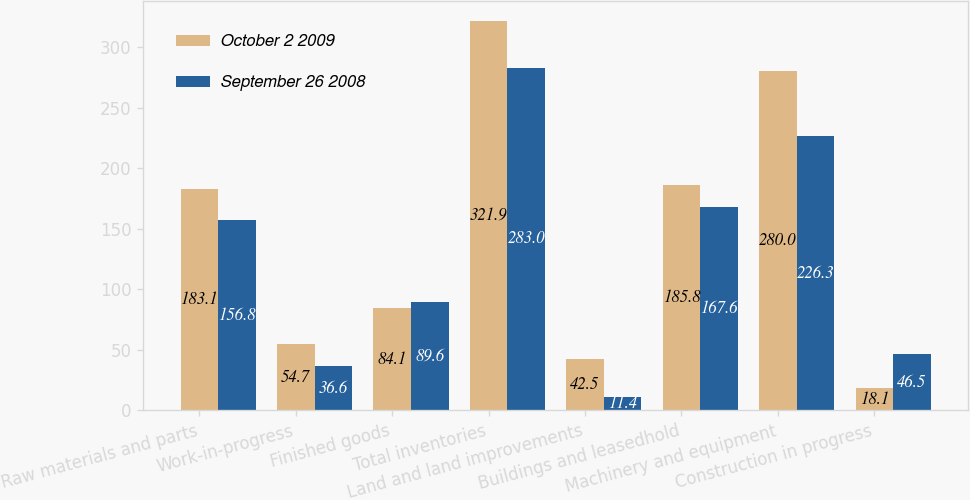Convert chart. <chart><loc_0><loc_0><loc_500><loc_500><stacked_bar_chart><ecel><fcel>Raw materials and parts<fcel>Work-in-progress<fcel>Finished goods<fcel>Total inventories<fcel>Land and land improvements<fcel>Buildings and leasedhold<fcel>Machinery and equipment<fcel>Construction in progress<nl><fcel>October 2 2009<fcel>183.1<fcel>54.7<fcel>84.1<fcel>321.9<fcel>42.5<fcel>185.8<fcel>280<fcel>18.1<nl><fcel>September 26 2008<fcel>156.8<fcel>36.6<fcel>89.6<fcel>283<fcel>11.4<fcel>167.6<fcel>226.3<fcel>46.5<nl></chart> 